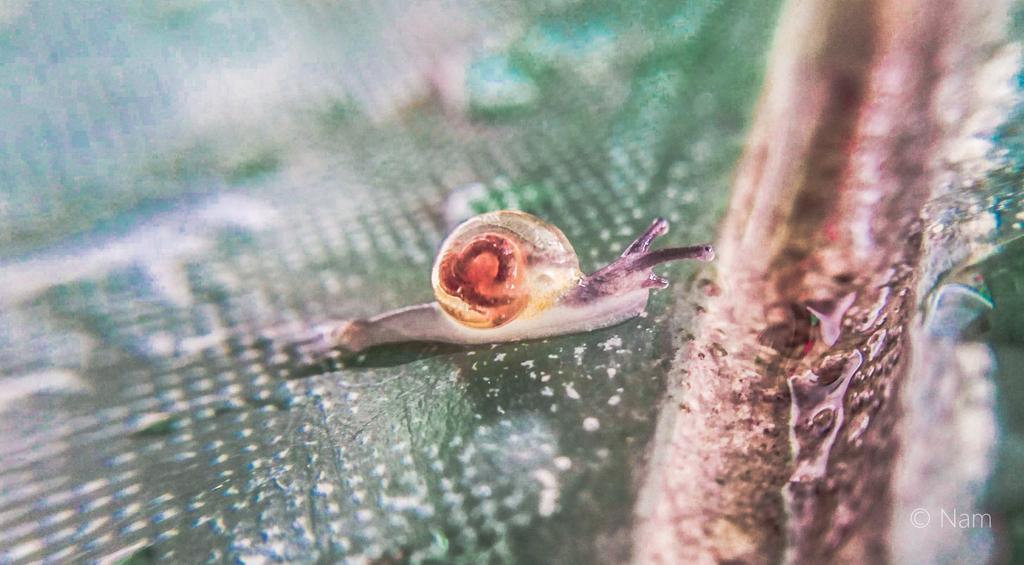Can you describe this image briefly? In this image we can see a snail on the surface. 